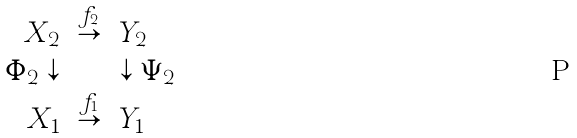<formula> <loc_0><loc_0><loc_500><loc_500>\begin{array} { r l l } X _ { 2 } & \stackrel { f _ { 2 } } { \rightarrow } & Y _ { 2 } \\ \Phi _ { 2 } \downarrow & & \downarrow \Psi _ { 2 } \\ X _ { 1 } & \stackrel { f _ { 1 } } { \rightarrow } & Y _ { 1 } \end{array}</formula> 